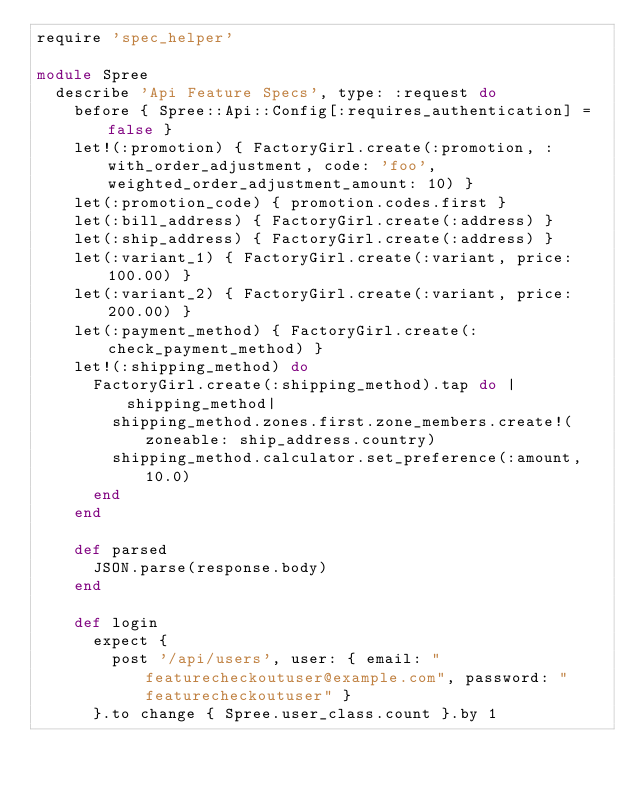<code> <loc_0><loc_0><loc_500><loc_500><_Ruby_>require 'spec_helper'

module Spree
  describe 'Api Feature Specs', type: :request do
    before { Spree::Api::Config[:requires_authentication] = false }
    let!(:promotion) { FactoryGirl.create(:promotion, :with_order_adjustment, code: 'foo', weighted_order_adjustment_amount: 10) }
    let(:promotion_code) { promotion.codes.first }
    let(:bill_address) { FactoryGirl.create(:address) }
    let(:ship_address) { FactoryGirl.create(:address) }
    let(:variant_1) { FactoryGirl.create(:variant, price: 100.00) }
    let(:variant_2) { FactoryGirl.create(:variant, price: 200.00) }
    let(:payment_method) { FactoryGirl.create(:check_payment_method) }
    let!(:shipping_method) do
      FactoryGirl.create(:shipping_method).tap do |shipping_method|
        shipping_method.zones.first.zone_members.create!(zoneable: ship_address.country)
        shipping_method.calculator.set_preference(:amount, 10.0)
      end
    end

    def parsed
      JSON.parse(response.body)
    end

    def login
      expect {
        post '/api/users', user: { email: "featurecheckoutuser@example.com", password: "featurecheckoutuser" }
      }.to change { Spree.user_class.count }.by 1</code> 